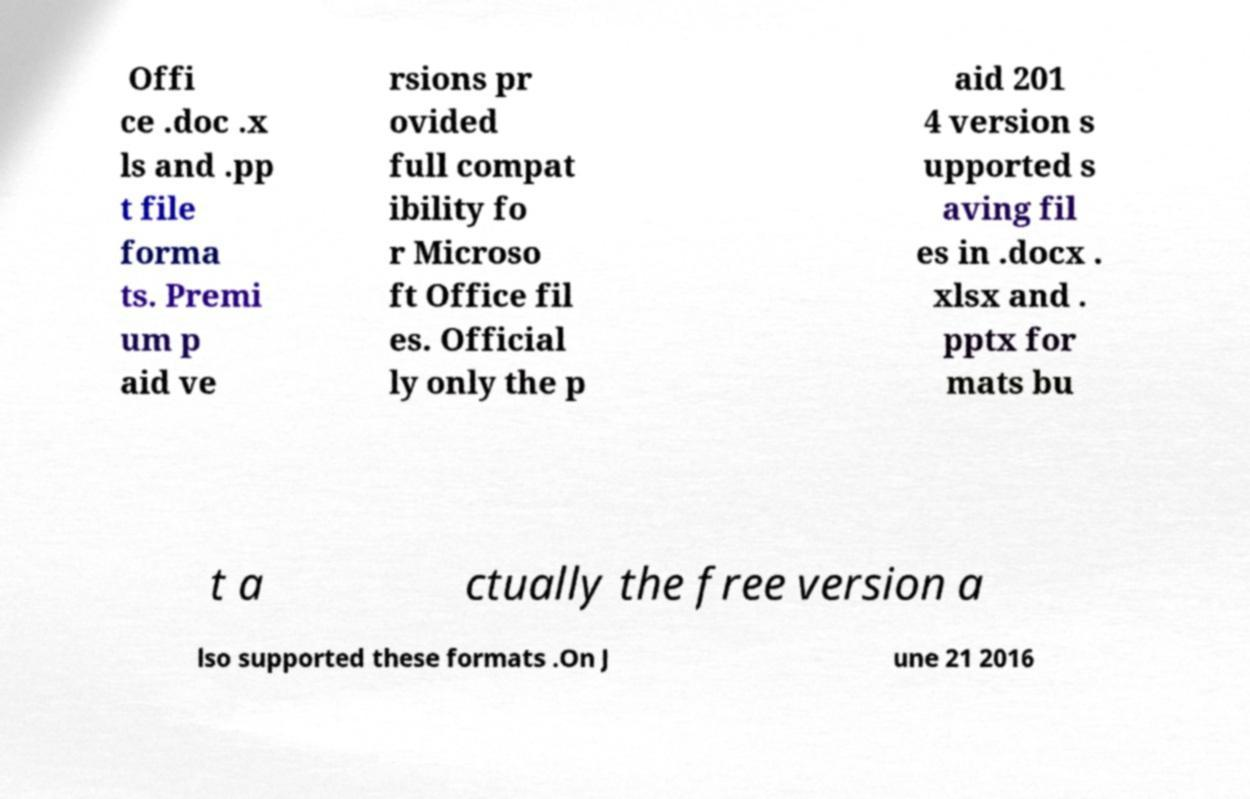Could you extract and type out the text from this image? Offi ce .doc .x ls and .pp t file forma ts. Premi um p aid ve rsions pr ovided full compat ibility fo r Microso ft Office fil es. Official ly only the p aid 201 4 version s upported s aving fil es in .docx . xlsx and . pptx for mats bu t a ctually the free version a lso supported these formats .On J une 21 2016 